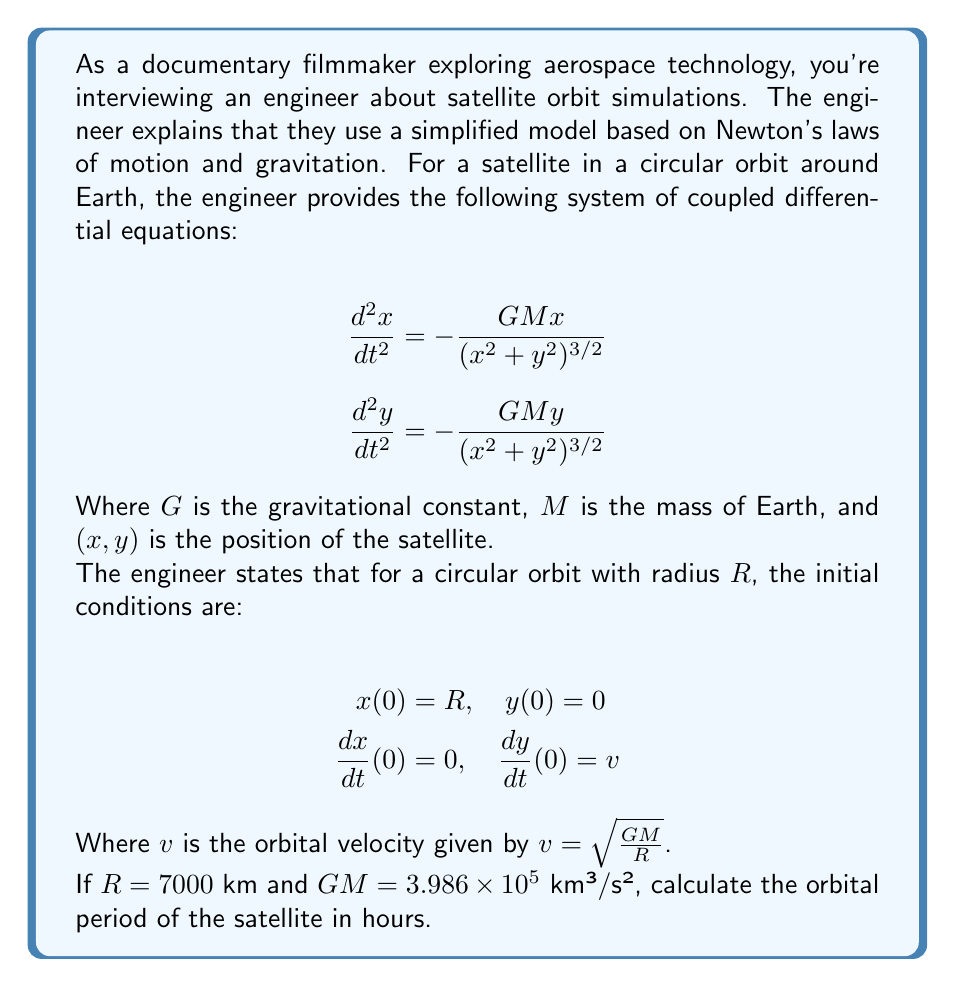Can you answer this question? To solve this problem, we'll follow these steps:

1) First, we need to calculate the orbital velocity $v$ using the given formula:

   $v = \sqrt{\frac{GM}{R}}$

   Substituting the values:
   $v = \sqrt{\frac{3.986 \times 10^5}{7000}} = 7.546$ km/s

2) Now, we need to find the orbital period. For a circular orbit, the period $T$ is related to the circumference of the orbit and the velocity:

   $T = \frac{2\pi R}{v}$

3) Substituting our values:

   $T = \frac{2\pi \cdot 7000}{7.546} = 5828.91$ seconds

4) To convert this to hours, we divide by 3600 (the number of seconds in an hour):

   $T = \frac{5828.91}{3600} = 1.619$ hours

Thus, the orbital period of the satellite is approximately 1.619 hours.

Note: In reality, satellite orbits are often elliptical rather than perfectly circular, and there are many other factors that can affect orbital motion (such as atmospheric drag for low Earth orbits, gravitational effects from the Moon and other celestial bodies, etc.). This simplified model provides a good approximation for many purposes, but more complex models are used for precise calculations in actual aerospace engineering applications.
Answer: The orbital period of the satellite is approximately 1.619 hours. 